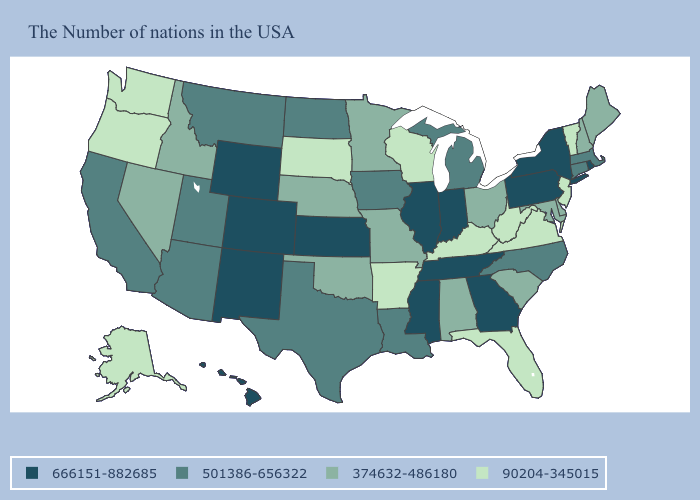What is the value of Nevada?
Quick response, please. 374632-486180. Name the states that have a value in the range 666151-882685?
Write a very short answer. Rhode Island, New York, Pennsylvania, Georgia, Indiana, Tennessee, Illinois, Mississippi, Kansas, Wyoming, Colorado, New Mexico, Hawaii. What is the value of Missouri?
Short answer required. 374632-486180. What is the value of Virginia?
Concise answer only. 90204-345015. Name the states that have a value in the range 90204-345015?
Be succinct. Vermont, New Jersey, Virginia, West Virginia, Florida, Kentucky, Wisconsin, Arkansas, South Dakota, Washington, Oregon, Alaska. Does Hawaii have the highest value in the USA?
Write a very short answer. Yes. Does North Dakota have a higher value than Montana?
Concise answer only. No. What is the value of Tennessee?
Concise answer only. 666151-882685. Among the states that border Oklahoma , does New Mexico have the lowest value?
Give a very brief answer. No. Which states hav the highest value in the MidWest?
Concise answer only. Indiana, Illinois, Kansas. Among the states that border Oregon , which have the lowest value?
Keep it brief. Washington. What is the value of Arkansas?
Write a very short answer. 90204-345015. Does Illinois have a lower value than Oregon?
Quick response, please. No. What is the value of Arizona?
Concise answer only. 501386-656322. Among the states that border Missouri , does Kentucky have the lowest value?
Concise answer only. Yes. 